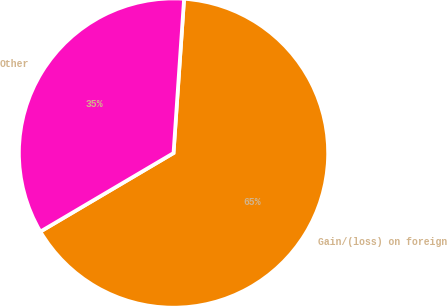Convert chart to OTSL. <chart><loc_0><loc_0><loc_500><loc_500><pie_chart><fcel>Gain/(loss) on foreign<fcel>Other<nl><fcel>65.43%<fcel>34.57%<nl></chart> 